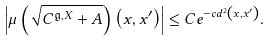<formula> <loc_0><loc_0><loc_500><loc_500>\left | \mu \left ( \sqrt { C ^ { \mathfrak g , X } + A } \right ) \left ( x , x ^ { \prime } \right ) \right | \leq C e ^ { - c d ^ { 2 } \left ( x , x ^ { \prime } \right ) } .</formula> 